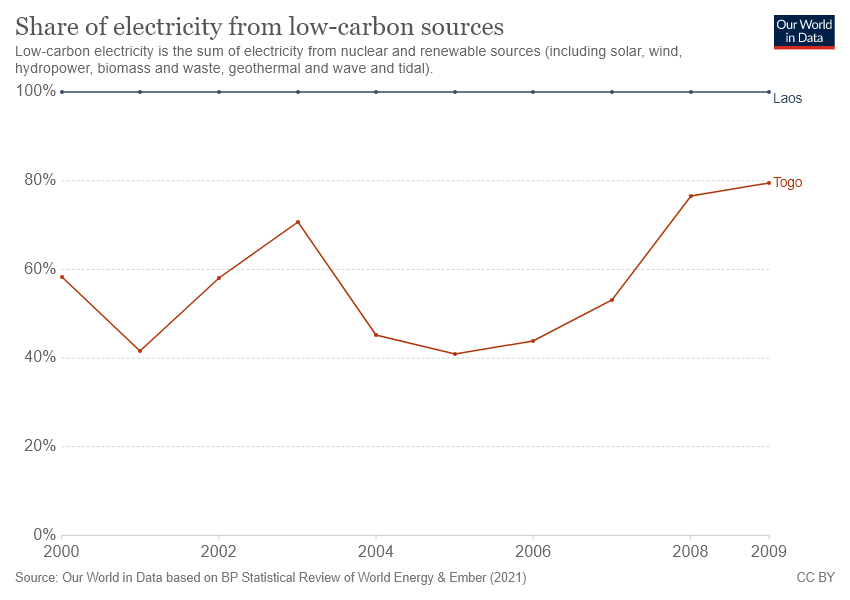Can you provide context on how Togo's trends compare with global patterns in low-carbon energy adoption during this time period? Globally, the early 2000s saw a growing recognition of renewable energy's importance for sustainable development and climate change mitigation. However, adoption rates varied by country due to differences in economic capability, resource availability, and political will. Togo's trends may indicate a focused effort to expand low-carbon energy infrastructure, possibly catching up with or even outpacing some global averages, especially in comparison to other countries with similar economic profiles. 